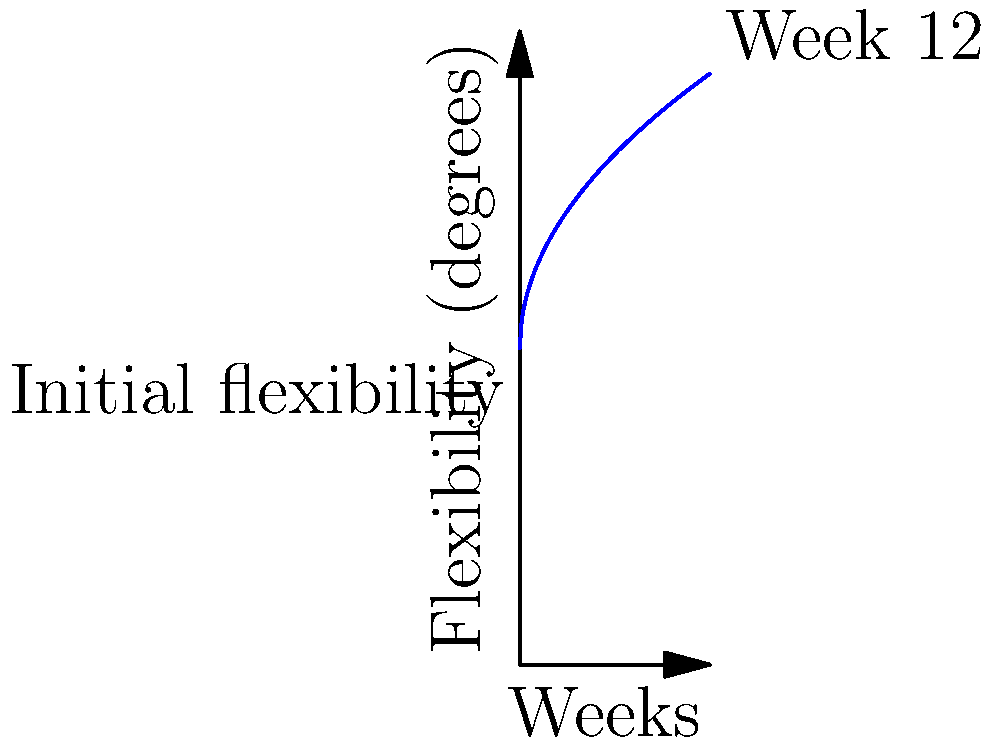As a novice yoga instructor incorporating Pilates principles, you're tracking a student's hamstring flexibility progress. The graph shows the increase in flexibility over 12 weeks, starting at 20 degrees. If the flexibility (y) in degrees is given by the function $y = 20 + 5\sqrt{x}$, where x is the number of weeks, what is the total increase in flexibility from the start to the end of the 12-week period? To find the total increase in flexibility, we need to:

1. Calculate the initial flexibility (at week 0):
   $y_0 = 20 + 5\sqrt{0} = 20$ degrees

2. Calculate the final flexibility (at week 12):
   $y_{12} = 20 + 5\sqrt{12} = 20 + 5 \cdot \sqrt{12} = 20 + 5 \cdot 3.464 = 37.32$ degrees

3. Calculate the difference between final and initial flexibility:
   Increase = $y_{12} - y_0 = 37.32 - 20 = 17.32$ degrees

Therefore, the total increase in flexibility over the 12-week period is approximately 17.32 degrees.
Answer: 17.32 degrees 